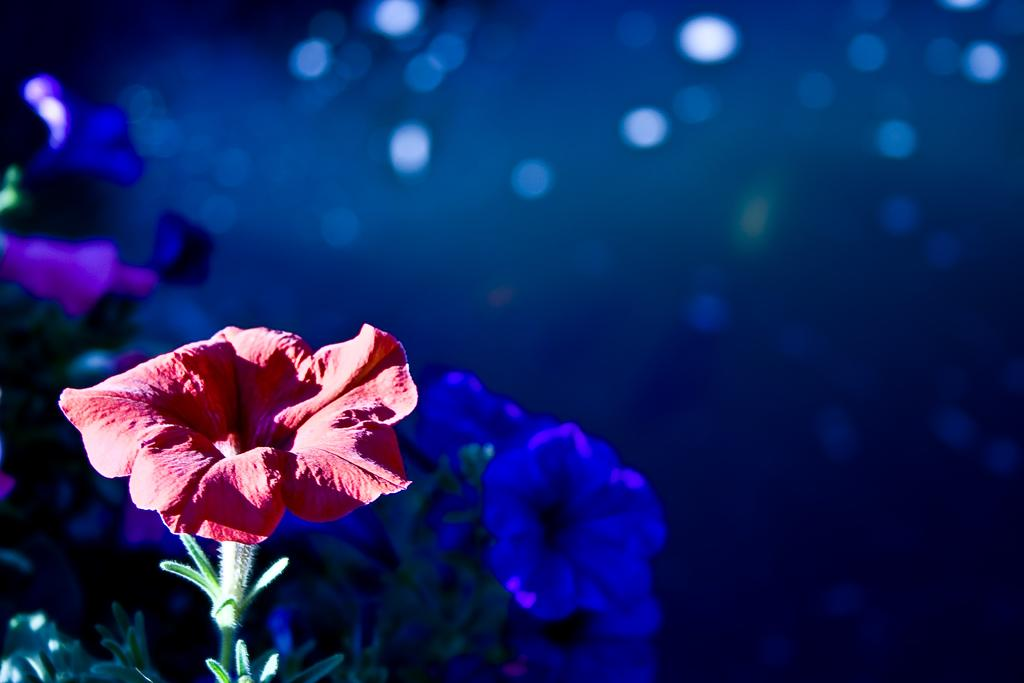What type of plants can be seen in the image? There are flowers in the image. What part of the flowers is visible in the image? There are stems in the image. What color is the background of the image? The background of the image is blue. What type of underwear is hanging on the street in the image? There is no underwear or street present in the image; it features flowers and a blue background. 